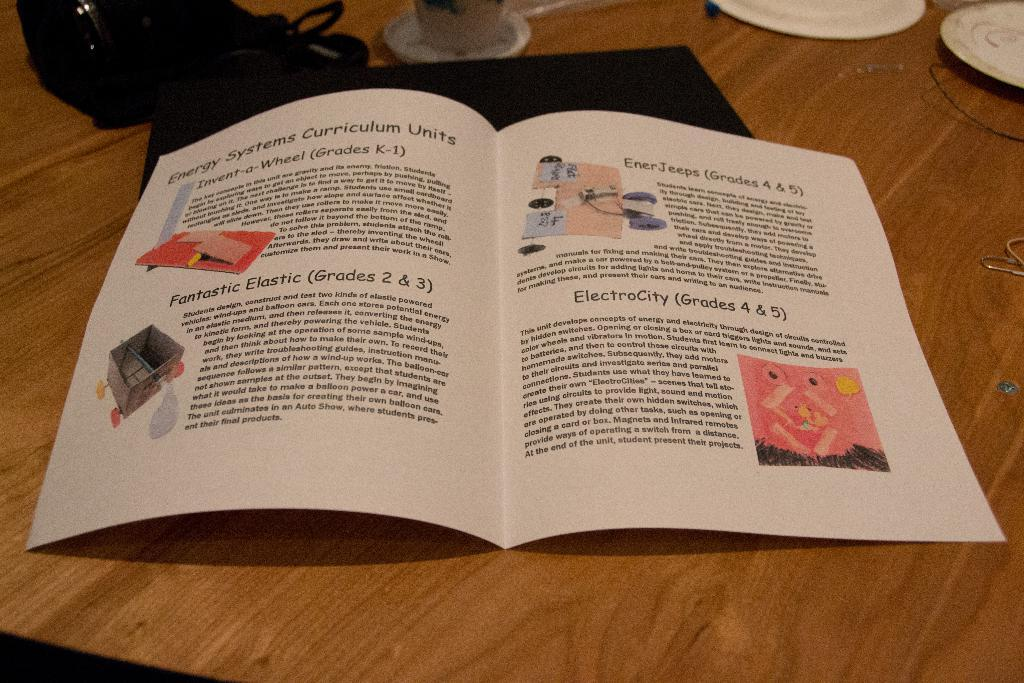<image>
Present a compact description of the photo's key features. A pamphlet for energy systems curriculum shows that grades 2 & 3 will do the Fantastic Elastic project. 